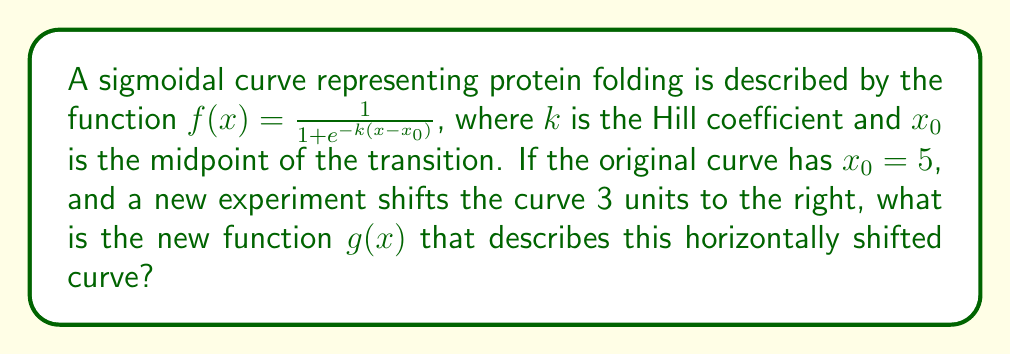Can you answer this question? To determine the horizontal shift of the sigmoidal curve, we need to follow these steps:

1) The original function is given as:
   $f(x) = \frac{1}{1 + e^{-k(x-x_0)}}$, where $x_0 = 5$

2) A horizontal shift of 3 units to the right means we replace $x$ with $(x-3)$ in the original function. This is because to shift right, we need to subtract from $x$.

3) Let's call the new function $g(x)$:
   $g(x) = \frac{1}{1 + e^{-k((x-3)-x_0)}}$

4) Simplify the expression inside the exponential:
   $g(x) = \frac{1}{1 + e^{-k(x-3-5)}}$
   $g(x) = \frac{1}{1 + e^{-k(x-8)}}$

5) We can see that the new midpoint $x_0$ is now 8, which confirms the 3-unit right shift from the original midpoint of 5.

Therefore, the new function $g(x)$ that describes the horizontally shifted curve is $g(x) = \frac{1}{1 + e^{-k(x-8)}}$.
Answer: $g(x) = \frac{1}{1 + e^{-k(x-8)}}$ 